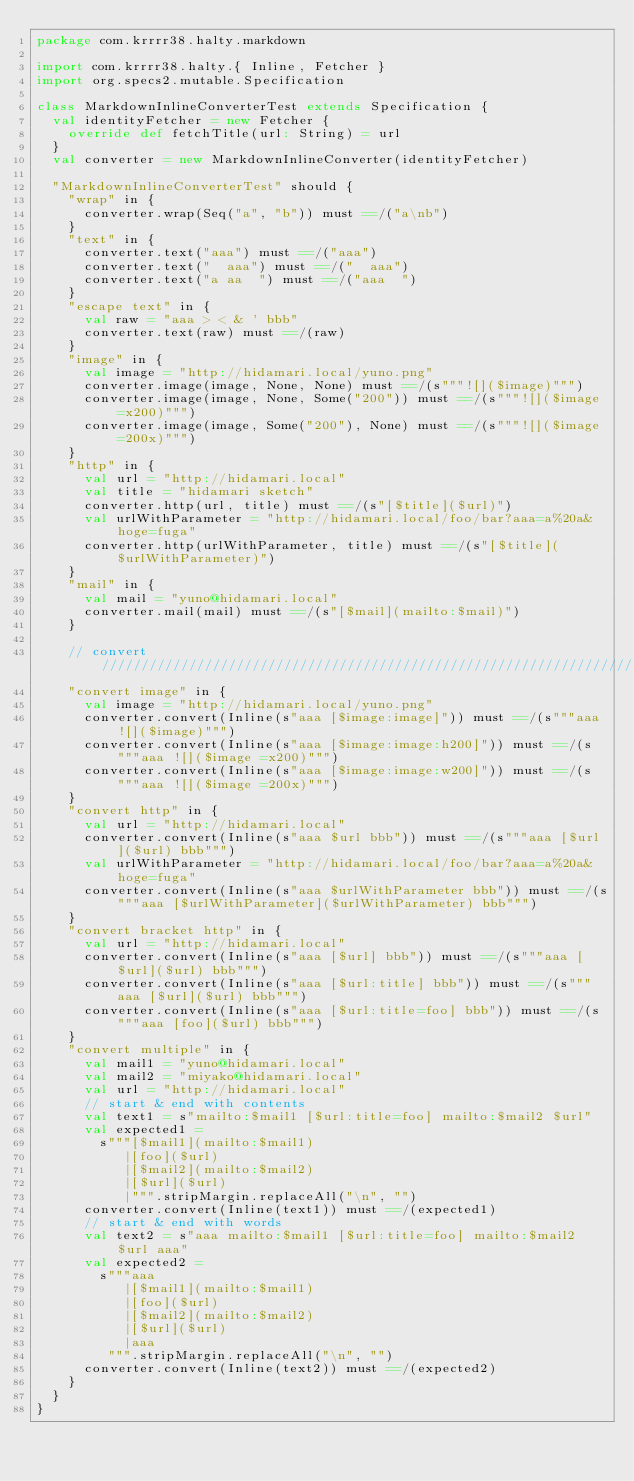Convert code to text. <code><loc_0><loc_0><loc_500><loc_500><_Scala_>package com.krrrr38.halty.markdown

import com.krrrr38.halty.{ Inline, Fetcher }
import org.specs2.mutable.Specification

class MarkdownInlineConverterTest extends Specification {
  val identityFetcher = new Fetcher {
    override def fetchTitle(url: String) = url
  }
  val converter = new MarkdownInlineConverter(identityFetcher)

  "MarkdownInlineConverterTest" should {
    "wrap" in {
      converter.wrap(Seq("a", "b")) must ==/("a\nb")
    }
    "text" in {
      converter.text("aaa") must ==/("aaa")
      converter.text("  aaa") must ==/("  aaa")
      converter.text("a aa  ") must ==/("aaa  ")
    }
    "escape text" in {
      val raw = "aaa > < & ' bbb"
      converter.text(raw) must ==/(raw)
    }
    "image" in {
      val image = "http://hidamari.local/yuno.png"
      converter.image(image, None, None) must ==/(s"""![]($image)""")
      converter.image(image, None, Some("200")) must ==/(s"""![]($image =x200)""")
      converter.image(image, Some("200"), None) must ==/(s"""![]($image =200x)""")
    }
    "http" in {
      val url = "http://hidamari.local"
      val title = "hidamari sketch"
      converter.http(url, title) must ==/(s"[$title]($url)")
      val urlWithParameter = "http://hidamari.local/foo/bar?aaa=a%20a&hoge=fuga"
      converter.http(urlWithParameter, title) must ==/(s"[$title]($urlWithParameter)")
    }
    "mail" in {
      val mail = "yuno@hidamari.local"
      converter.mail(mail) must ==/(s"[$mail](mailto:$mail)")
    }

    // convert ///////////////////////////////////////////////////////////////////////////////
    "convert image" in {
      val image = "http://hidamari.local/yuno.png"
      converter.convert(Inline(s"aaa [$image:image]")) must ==/(s"""aaa ![]($image)""")
      converter.convert(Inline(s"aaa [$image:image:h200]")) must ==/(s"""aaa ![]($image =x200)""")
      converter.convert(Inline(s"aaa [$image:image:w200]")) must ==/(s"""aaa ![]($image =200x)""")
    }
    "convert http" in {
      val url = "http://hidamari.local"
      converter.convert(Inline(s"aaa $url bbb")) must ==/(s"""aaa [$url]($url) bbb""")
      val urlWithParameter = "http://hidamari.local/foo/bar?aaa=a%20a&hoge=fuga"
      converter.convert(Inline(s"aaa $urlWithParameter bbb")) must ==/(s"""aaa [$urlWithParameter]($urlWithParameter) bbb""")
    }
    "convert bracket http" in {
      val url = "http://hidamari.local"
      converter.convert(Inline(s"aaa [$url] bbb")) must ==/(s"""aaa [$url]($url) bbb""")
      converter.convert(Inline(s"aaa [$url:title] bbb")) must ==/(s"""aaa [$url]($url) bbb""")
      converter.convert(Inline(s"aaa [$url:title=foo] bbb")) must ==/(s"""aaa [foo]($url) bbb""")
    }
    "convert multiple" in {
      val mail1 = "yuno@hidamari.local"
      val mail2 = "miyako@hidamari.local"
      val url = "http://hidamari.local"
      // start & end with contents
      val text1 = s"mailto:$mail1 [$url:title=foo] mailto:$mail2 $url"
      val expected1 =
        s"""[$mail1](mailto:$mail1)
           |[foo]($url)
           |[$mail2](mailto:$mail2)
           |[$url]($url)
           |""".stripMargin.replaceAll("\n", "")
      converter.convert(Inline(text1)) must ==/(expected1)
      // start & end with words
      val text2 = s"aaa mailto:$mail1 [$url:title=foo] mailto:$mail2 $url aaa"
      val expected2 =
        s"""aaa
           |[$mail1](mailto:$mail1)
           |[foo]($url)
           |[$mail2](mailto:$mail2)
           |[$url]($url)
           |aaa
         """.stripMargin.replaceAll("\n", "")
      converter.convert(Inline(text2)) must ==/(expected2)
    }
  }
}</code> 